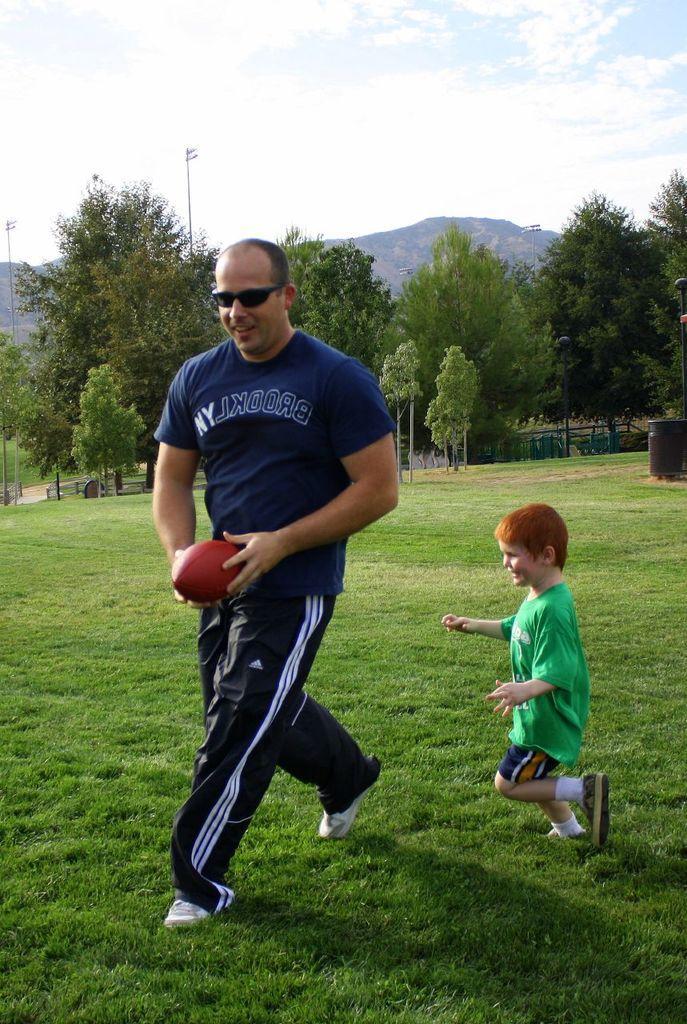Describe this image in one or two sentences. in the center we can see one man standing he is holding ball. Beside him we can see one boy. Coming to the background we can see the sky with clouds and mountain and trees. 